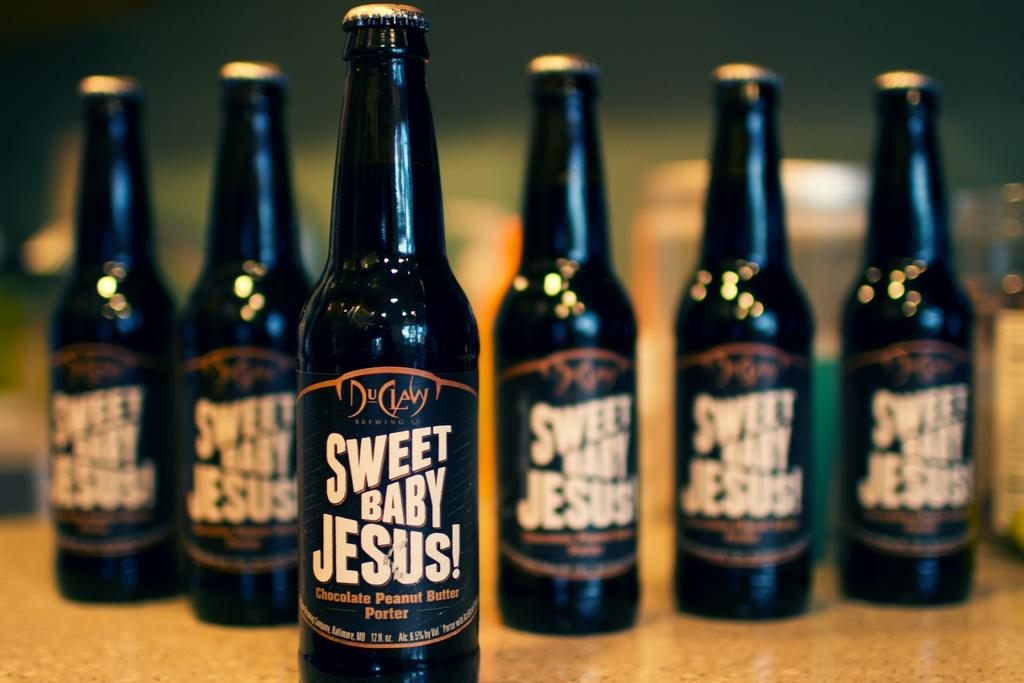<image>
Offer a succinct explanation of the picture presented. Five bottles of Sweet Baby Jesus beer are sitting on a table. 